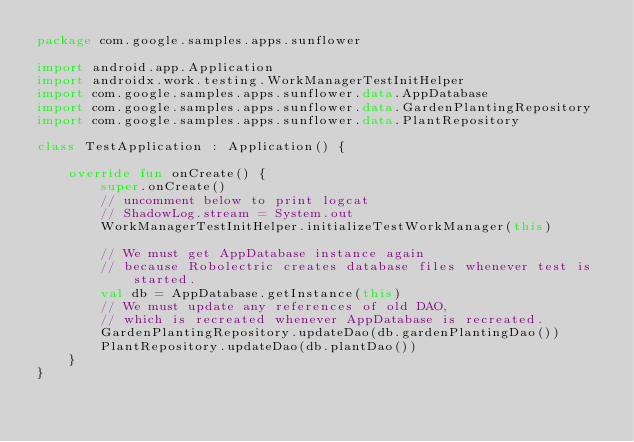<code> <loc_0><loc_0><loc_500><loc_500><_Kotlin_>package com.google.samples.apps.sunflower

import android.app.Application
import androidx.work.testing.WorkManagerTestInitHelper
import com.google.samples.apps.sunflower.data.AppDatabase
import com.google.samples.apps.sunflower.data.GardenPlantingRepository
import com.google.samples.apps.sunflower.data.PlantRepository

class TestApplication : Application() {

    override fun onCreate() {
        super.onCreate()
        // uncomment below to print logcat
        // ShadowLog.stream = System.out
        WorkManagerTestInitHelper.initializeTestWorkManager(this)

        // We must get AppDatabase instance again
        // because Robolectric creates database files whenever test is started.
        val db = AppDatabase.getInstance(this)
        // We must update any references of old DAO,
        // which is recreated whenever AppDatabase is recreated.
        GardenPlantingRepository.updateDao(db.gardenPlantingDao())
        PlantRepository.updateDao(db.plantDao())
    }
}</code> 